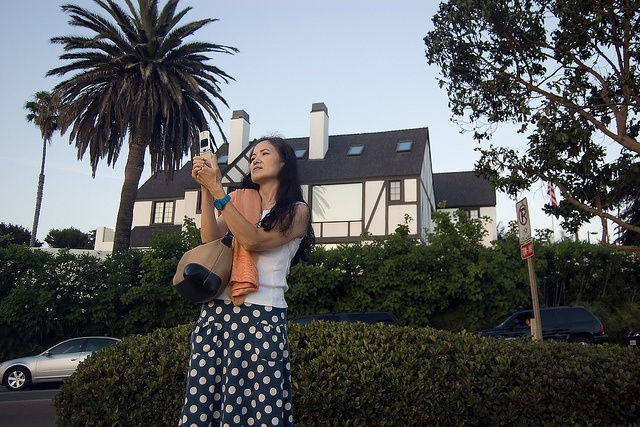Describe the objects in this image and their specific colors. I can see people in darkgray, black, and gray tones, handbag in darkgray, black, gray, and tan tones, car in darkgray, black, gray, and lightgray tones, car in darkgray, black, gray, and maroon tones, and car in darkgray, black, darkgreen, and gray tones in this image. 